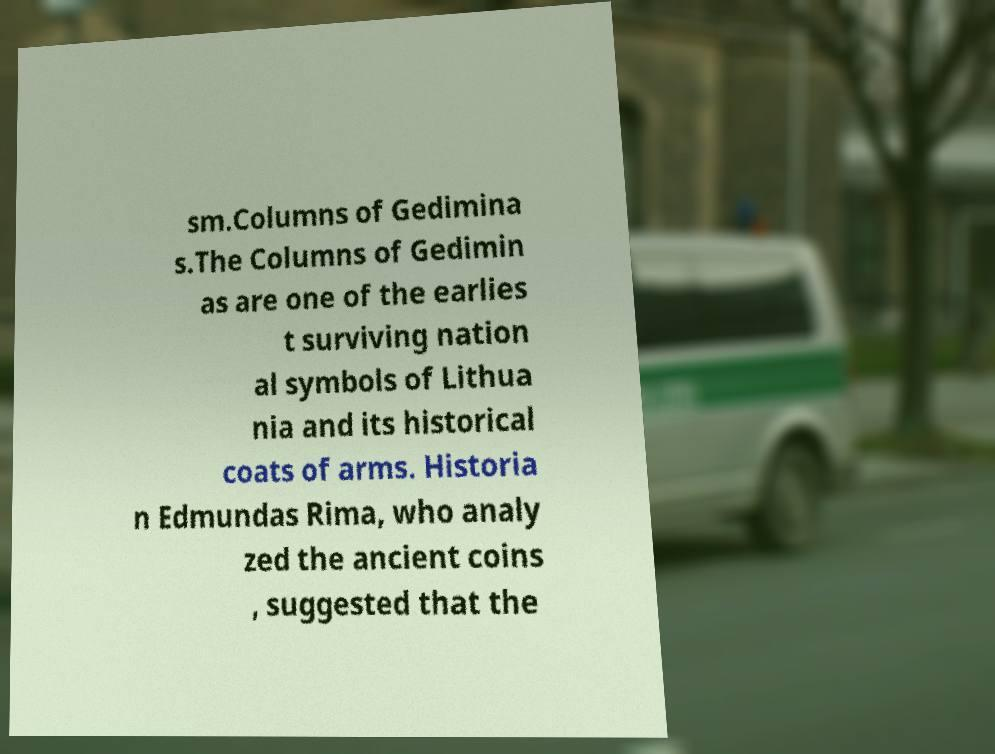There's text embedded in this image that I need extracted. Can you transcribe it verbatim? sm.Columns of Gedimina s.The Columns of Gedimin as are one of the earlies t surviving nation al symbols of Lithua nia and its historical coats of arms. Historia n Edmundas Rima, who analy zed the ancient coins , suggested that the 